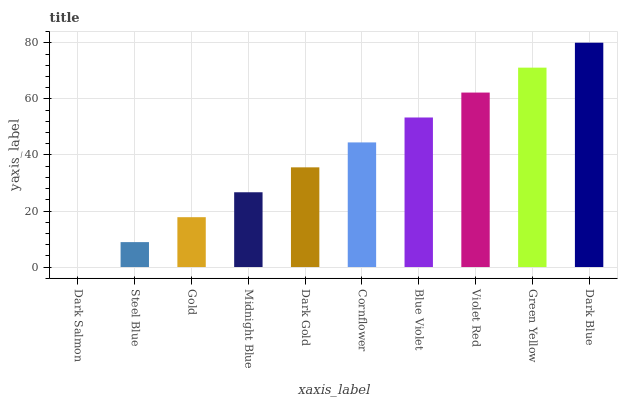Is Dark Salmon the minimum?
Answer yes or no. Yes. Is Dark Blue the maximum?
Answer yes or no. Yes. Is Steel Blue the minimum?
Answer yes or no. No. Is Steel Blue the maximum?
Answer yes or no. No. Is Steel Blue greater than Dark Salmon?
Answer yes or no. Yes. Is Dark Salmon less than Steel Blue?
Answer yes or no. Yes. Is Dark Salmon greater than Steel Blue?
Answer yes or no. No. Is Steel Blue less than Dark Salmon?
Answer yes or no. No. Is Cornflower the high median?
Answer yes or no. Yes. Is Dark Gold the low median?
Answer yes or no. Yes. Is Dark Gold the high median?
Answer yes or no. No. Is Gold the low median?
Answer yes or no. No. 